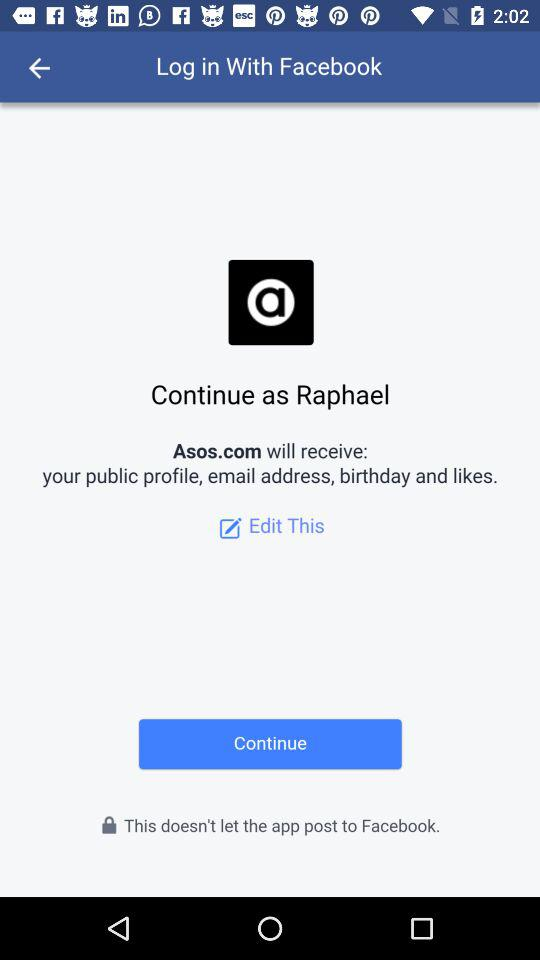What website will receive the public profile, email address, birthday and likes? The website that will receive the public profile, email address, birthday and likes is Asos.com. 